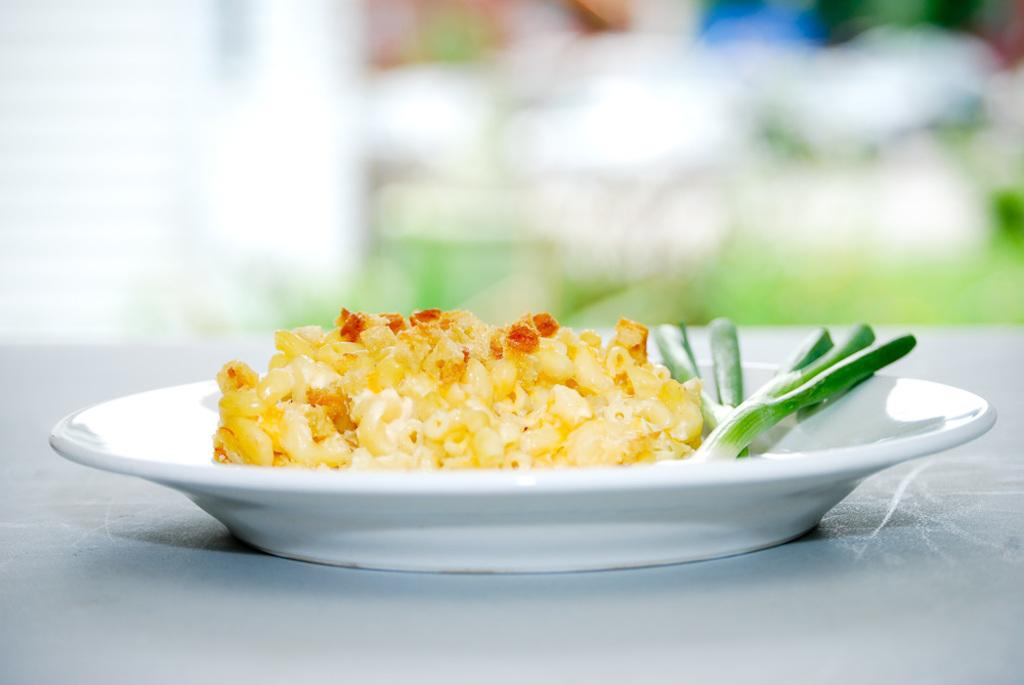What is on the plate that is visible in the image? There is food on a plate in the image. Where is the plate located in the image? The plate is placed on a table. Can you describe the background of the image? The background of the image is not clear, so it is difficult to provide a detailed description. What type of plants can be seen growing on the plane in the image? There is no plane present in the image, and therefore no plants growing on it. 